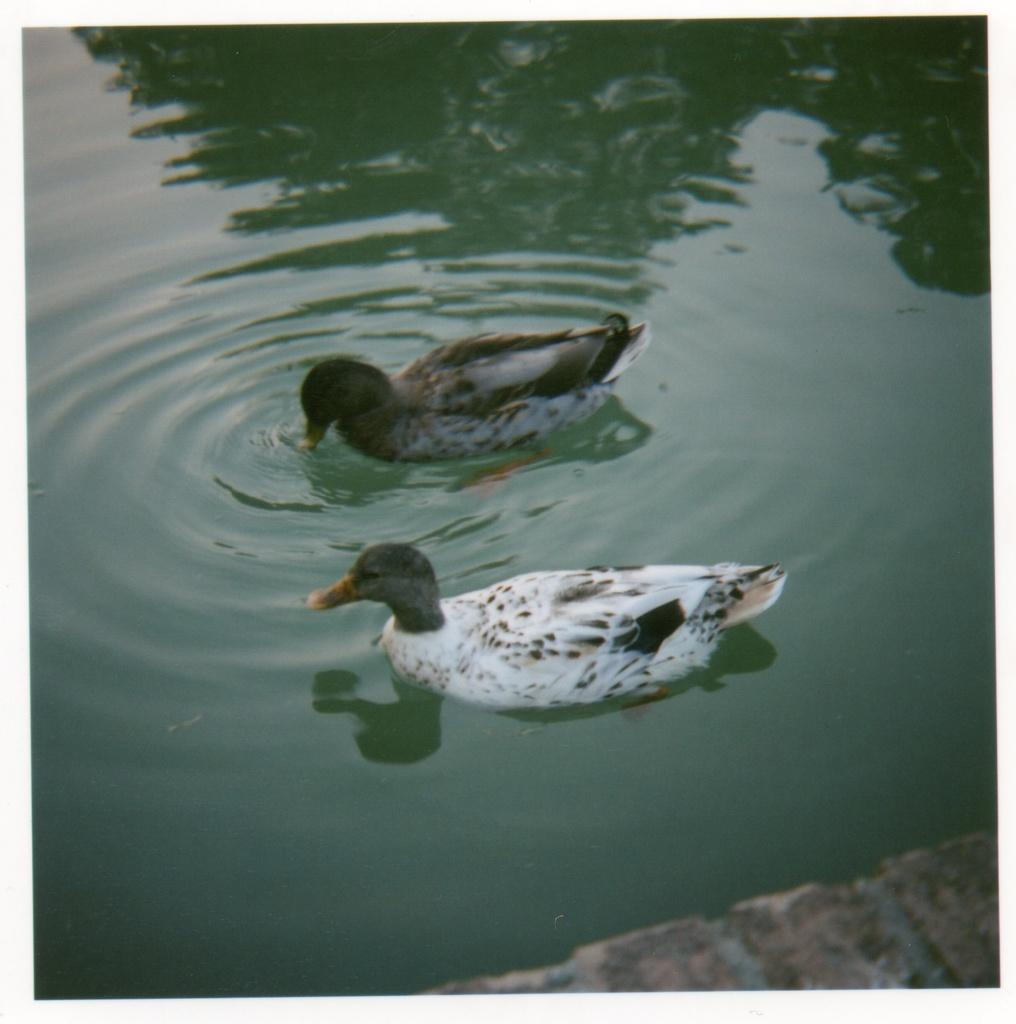What is the primary element visible in the image? There is water in the image. What type of animals can be seen in the water? There are two birds in the water. What parcel is being delivered to the birds in the image? There is no parcel visible in the image, and no indication that the birds are expecting a delivery. 